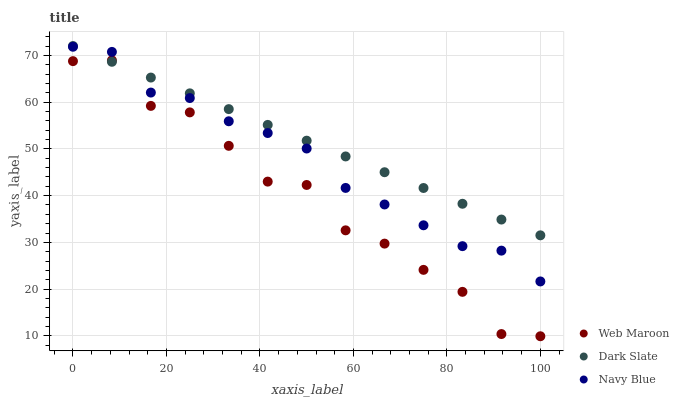Does Web Maroon have the minimum area under the curve?
Answer yes or no. Yes. Does Dark Slate have the maximum area under the curve?
Answer yes or no. Yes. Does Navy Blue have the minimum area under the curve?
Answer yes or no. No. Does Navy Blue have the maximum area under the curve?
Answer yes or no. No. Is Dark Slate the smoothest?
Answer yes or no. Yes. Is Web Maroon the roughest?
Answer yes or no. Yes. Is Navy Blue the smoothest?
Answer yes or no. No. Is Navy Blue the roughest?
Answer yes or no. No. Does Web Maroon have the lowest value?
Answer yes or no. Yes. Does Navy Blue have the lowest value?
Answer yes or no. No. Does Dark Slate have the highest value?
Answer yes or no. Yes. Does Navy Blue have the highest value?
Answer yes or no. No. Is Web Maroon less than Navy Blue?
Answer yes or no. Yes. Is Navy Blue greater than Web Maroon?
Answer yes or no. Yes. Does Navy Blue intersect Dark Slate?
Answer yes or no. Yes. Is Navy Blue less than Dark Slate?
Answer yes or no. No. Is Navy Blue greater than Dark Slate?
Answer yes or no. No. Does Web Maroon intersect Navy Blue?
Answer yes or no. No. 